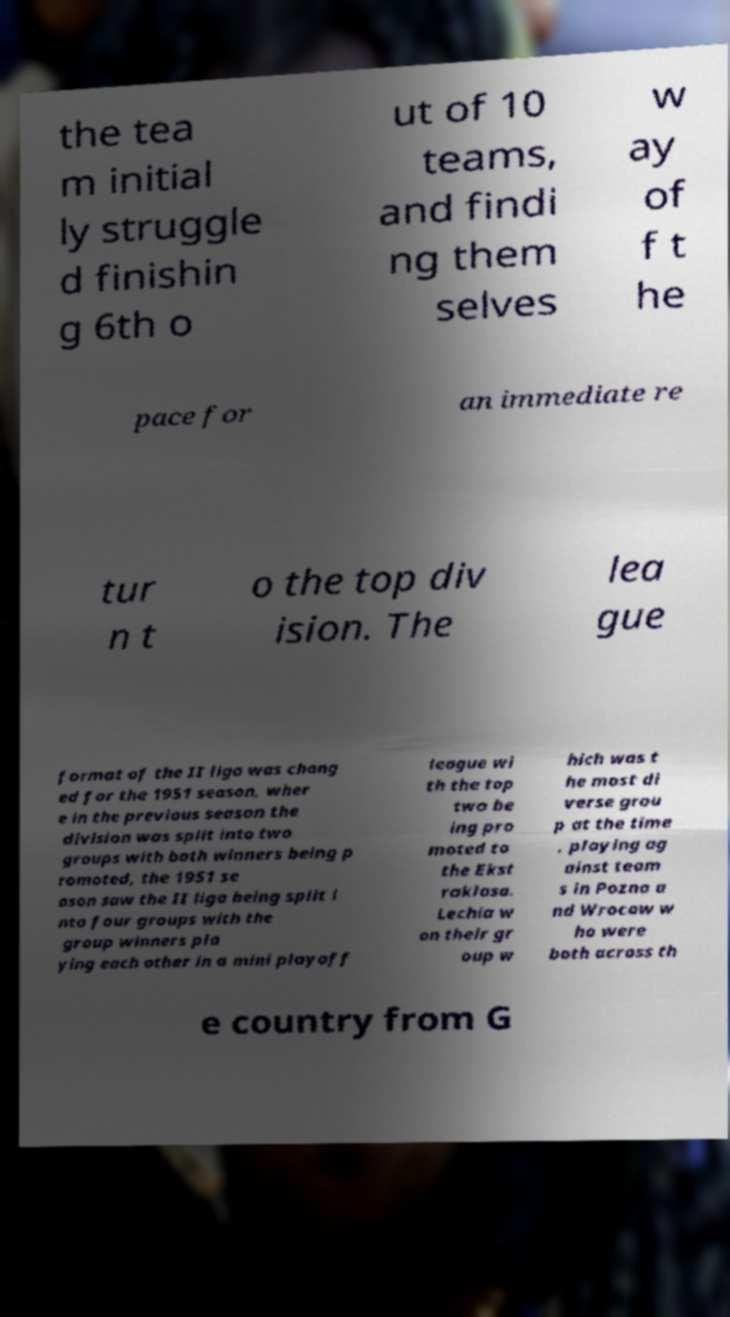Please identify and transcribe the text found in this image. the tea m initial ly struggle d finishin g 6th o ut of 10 teams, and findi ng them selves w ay of f t he pace for an immediate re tur n t o the top div ision. The lea gue format of the II liga was chang ed for the 1951 season, wher e in the previous season the division was split into two groups with both winners being p romoted, the 1951 se ason saw the II liga being split i nto four groups with the group winners pla ying each other in a mini playoff league wi th the top two be ing pro moted to the Ekst raklasa. Lechia w on their gr oup w hich was t he most di verse grou p at the time , playing ag ainst team s in Pozna a nd Wrocaw w ho were both across th e country from G 